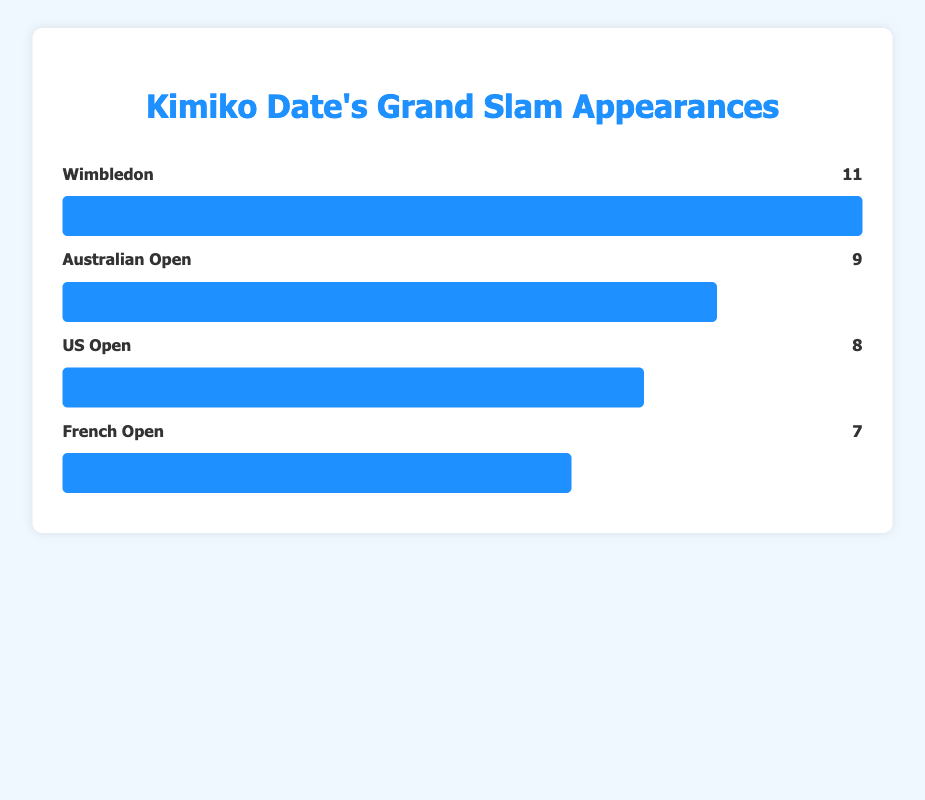Which Grand Slam did Kimiko Date appear in the most? Looking at the lengths of the bars, the longest bar represents Wimbledon with 11 appearances, making it the Grand Slam where she appeared the most.
Answer: Wimbledon Which Grand Slam did Kimiko Date appear in the least? The shortest bar represents the French Open with 7 appearances, making it the Grand Slam where she appeared the least.
Answer: French Open How many more appearances did Kimiko Date have in Wimbledon compared to the French Open? Wimbledon has 11 appearances, and the French Open has 7. The difference is 11 - 7 = 4.
Answer: 4 What is the total number of Grand Slam appearances Kimiko Date has made? Adding up the appearances for all the Grand Slams: 9 (Australian Open) + 7 (French Open) + 11 (Wimbledon) + 8 (US Open) = 35.
Answer: 35 What is the average number of appearances per Grand Slam? The total number of appearances across all Grand Slams is 35. There are 4 Grand Slams, so the average is 35 / 4 = 8.75.
Answer: 8.75 Which Grand Slam has a bar that is approximately 82% the length of the longest bar? The longest bar is Wimbledon with a length representing 11 appearances. 82% of 11 is approximately 9 (11 * 0.818 ≈ 9). The Australian Open has 9 appearances.
Answer: Australian Open Does Kimiko Date have more appearances in the Australian Open or the US Open? The Australian Open bar represents 9 appearances, whereas the US Open bar represents 8 appearances. 9 is greater than 8.
Answer: Australian Open If Kimiko Date had 2 more appearances in the French Open, how would its rank change in terms of appearances? Currently, the French Open has 7 appearances, ranking it last. If she had 2 more appearances, the French Open would have 9, matching the Australian Open, making it tied for the second rank.
Answer: Second How much longer is the bar for Wimbledon compared to the bar for the US Open in terms of percentage? The bar for Wimbledon (11 appearances) is longer than the bar for the US Open (8 appearances). The percentage difference is [(11 - 8) / 8] * 100% = 37.5%.
Answer: 37.5% Which tournament has a bar length closest to 73% of the longest bar's length? The longest bar represents 11 appearances (Wimbledon). 73% of 11 is approximately 8 (11 * 0.727 ≈ 8). The US Open has 8 appearances.
Answer: US Open 